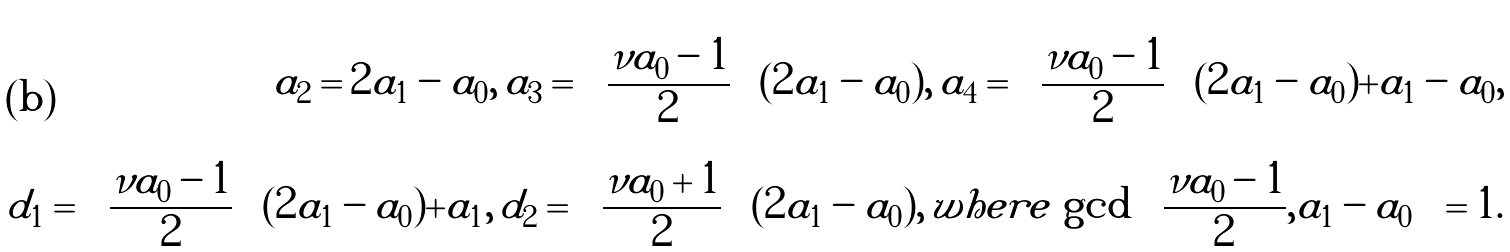<formula> <loc_0><loc_0><loc_500><loc_500>a _ { 2 } = 2 a _ { 1 } - a _ { 0 } , \, a _ { 3 } = \left ( \frac { \nu a _ { 0 } - 1 } { 2 } \right ) ( 2 a _ { 1 } - a _ { 0 } ) , \, a _ { 4 } = \left ( \frac { \nu a _ { 0 } - 1 } { 2 } \right ) ( 2 a _ { 1 } - a _ { 0 } ) + a _ { 1 } - a _ { 0 } , \\ d _ { 1 } = \left ( \frac { \nu a _ { 0 } - 1 } { 2 } \right ) ( 2 a _ { 1 } - a _ { 0 } ) + a _ { 1 } , \, d _ { 2 } = \left ( \frac { \nu a _ { 0 } + 1 } { 2 } \right ) ( 2 a _ { 1 } - a _ { 0 } ) , \, w h e r e \, \gcd \left ( \frac { \nu a _ { 0 } - 1 } { 2 } , a _ { 1 } - a _ { 0 } \right ) = 1 .</formula> 